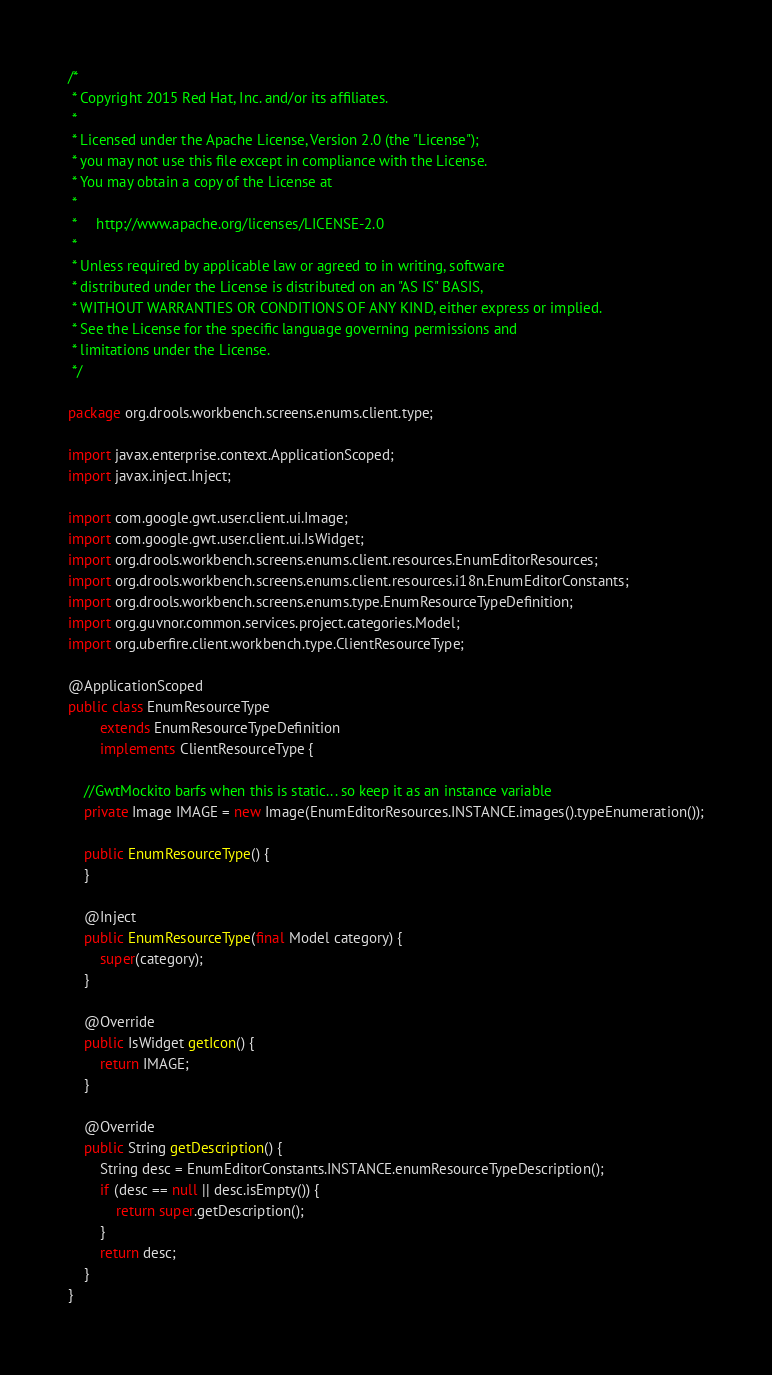Convert code to text. <code><loc_0><loc_0><loc_500><loc_500><_Java_>/*
 * Copyright 2015 Red Hat, Inc. and/or its affiliates.
 *
 * Licensed under the Apache License, Version 2.0 (the "License");
 * you may not use this file except in compliance with the License.
 * You may obtain a copy of the License at
 *
 *     http://www.apache.org/licenses/LICENSE-2.0
 *
 * Unless required by applicable law or agreed to in writing, software
 * distributed under the License is distributed on an "AS IS" BASIS,
 * WITHOUT WARRANTIES OR CONDITIONS OF ANY KIND, either express or implied.
 * See the License for the specific language governing permissions and
 * limitations under the License.
 */

package org.drools.workbench.screens.enums.client.type;

import javax.enterprise.context.ApplicationScoped;
import javax.inject.Inject;

import com.google.gwt.user.client.ui.Image;
import com.google.gwt.user.client.ui.IsWidget;
import org.drools.workbench.screens.enums.client.resources.EnumEditorResources;
import org.drools.workbench.screens.enums.client.resources.i18n.EnumEditorConstants;
import org.drools.workbench.screens.enums.type.EnumResourceTypeDefinition;
import org.guvnor.common.services.project.categories.Model;
import org.uberfire.client.workbench.type.ClientResourceType;

@ApplicationScoped
public class EnumResourceType
        extends EnumResourceTypeDefinition
        implements ClientResourceType {

    //GwtMockito barfs when this is static... so keep it as an instance variable
    private Image IMAGE = new Image(EnumEditorResources.INSTANCE.images().typeEnumeration());

    public EnumResourceType() {
    }

    @Inject
    public EnumResourceType(final Model category) {
        super(category);
    }

    @Override
    public IsWidget getIcon() {
        return IMAGE;
    }

    @Override
    public String getDescription() {
        String desc = EnumEditorConstants.INSTANCE.enumResourceTypeDescription();
        if (desc == null || desc.isEmpty()) {
            return super.getDescription();
        }
        return desc;
    }
}
</code> 